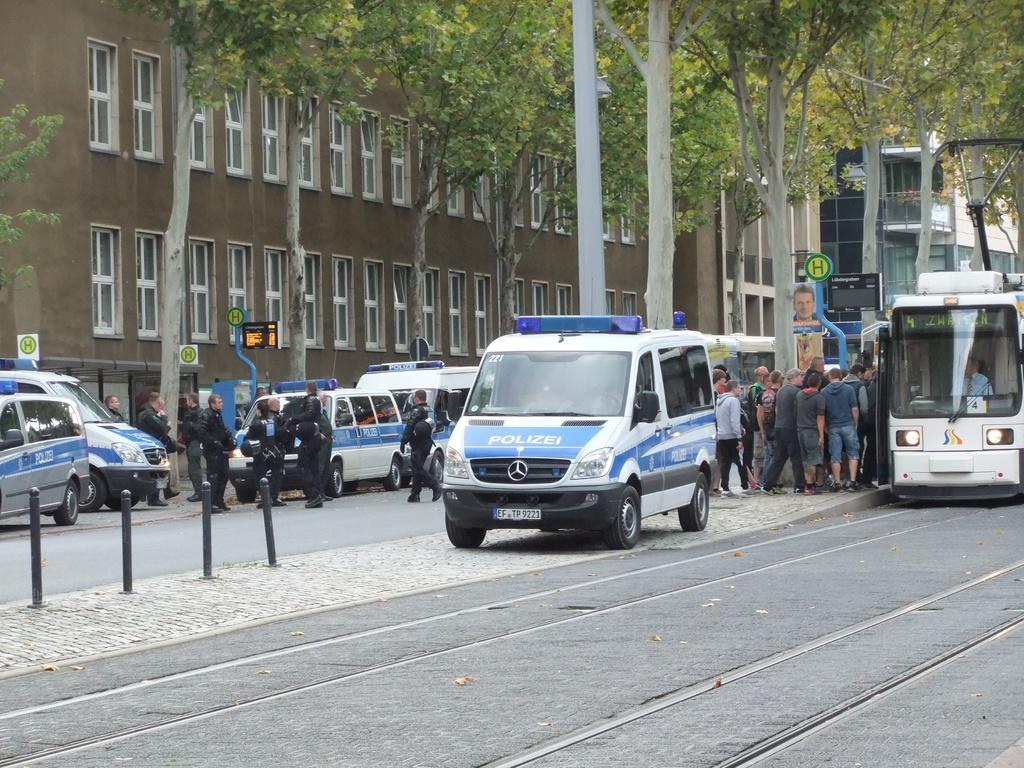<image>
Write a terse but informative summary of the picture. A busy street with pedestrians, a bus and Polizei cars. 